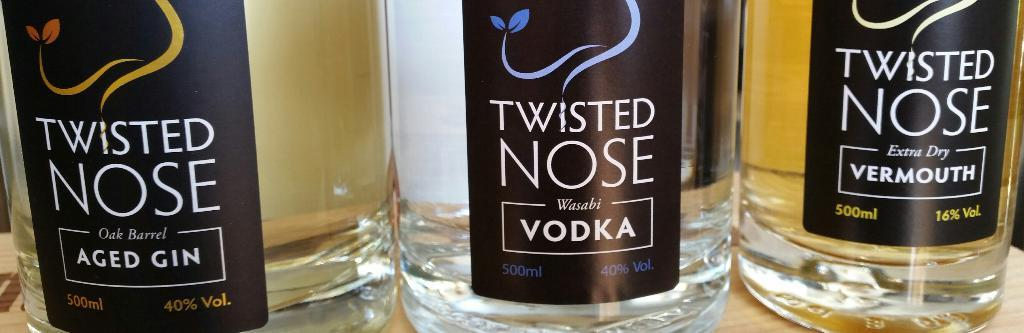<image>
Give a short and clear explanation of the subsequent image. Three bottles of Twister Nose alcohol on a wooden table. 